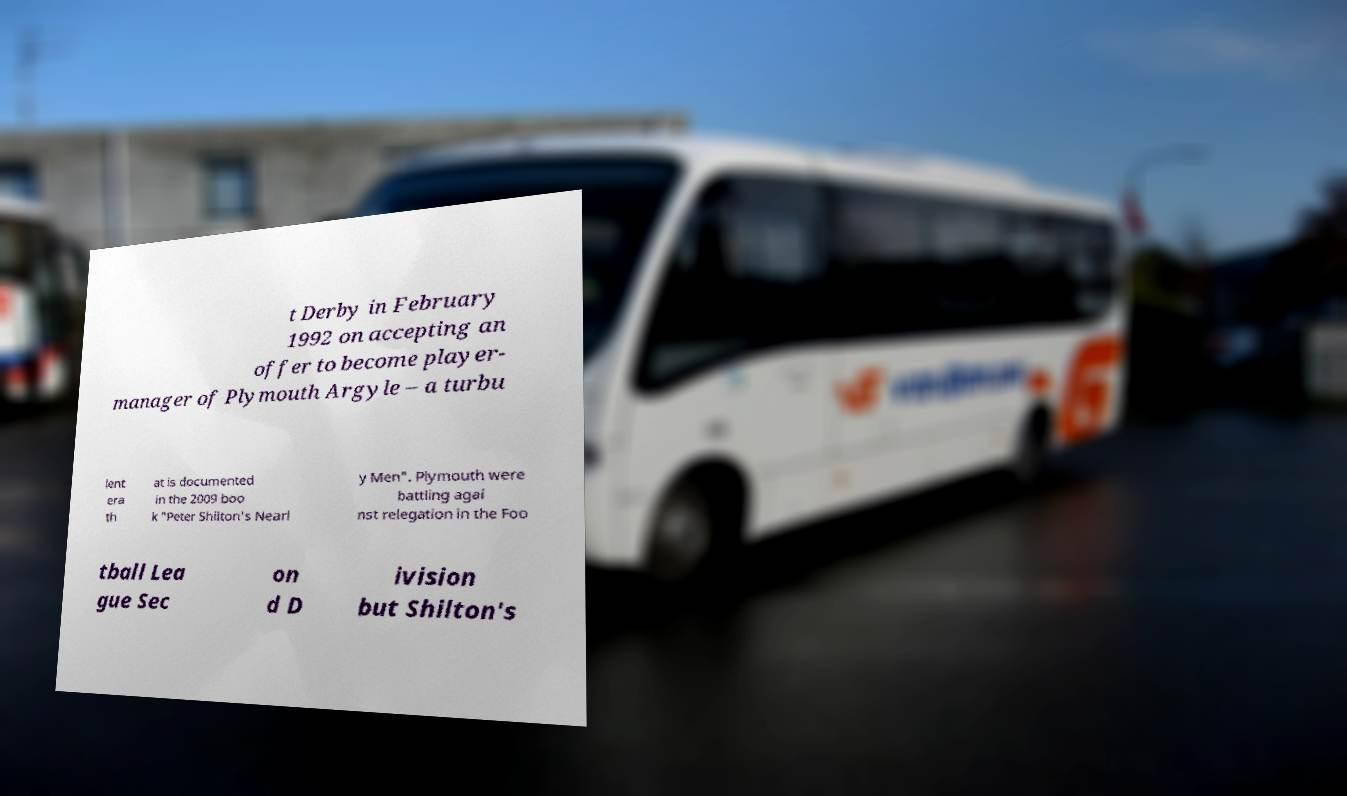Please identify and transcribe the text found in this image. t Derby in February 1992 on accepting an offer to become player- manager of Plymouth Argyle – a turbu lent era th at is documented in the 2009 boo k "Peter Shilton's Nearl y Men". Plymouth were battling agai nst relegation in the Foo tball Lea gue Sec on d D ivision but Shilton's 